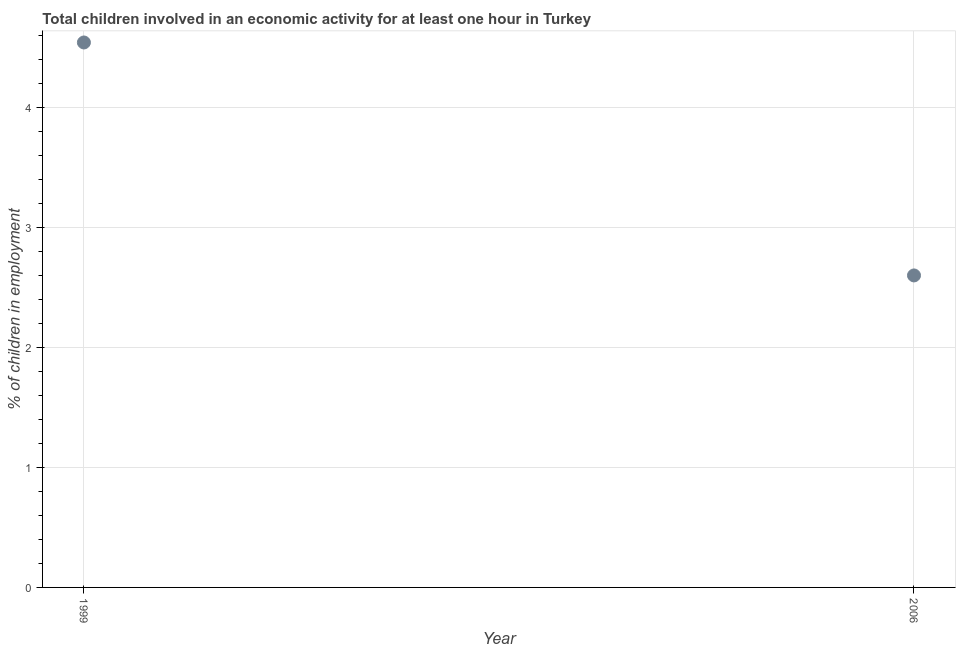What is the percentage of children in employment in 1999?
Ensure brevity in your answer.  4.54. Across all years, what is the maximum percentage of children in employment?
Offer a terse response. 4.54. Across all years, what is the minimum percentage of children in employment?
Your answer should be compact. 2.6. What is the sum of the percentage of children in employment?
Offer a terse response. 7.14. What is the difference between the percentage of children in employment in 1999 and 2006?
Offer a terse response. 1.94. What is the average percentage of children in employment per year?
Your response must be concise. 3.57. What is the median percentage of children in employment?
Offer a terse response. 3.57. Do a majority of the years between 2006 and 1999 (inclusive) have percentage of children in employment greater than 4 %?
Make the answer very short. No. What is the ratio of the percentage of children in employment in 1999 to that in 2006?
Your response must be concise. 1.75. How many dotlines are there?
Your answer should be compact. 1. How many years are there in the graph?
Your answer should be very brief. 2. Does the graph contain any zero values?
Your answer should be compact. No. Does the graph contain grids?
Offer a terse response. Yes. What is the title of the graph?
Your answer should be compact. Total children involved in an economic activity for at least one hour in Turkey. What is the label or title of the X-axis?
Ensure brevity in your answer.  Year. What is the label or title of the Y-axis?
Your response must be concise. % of children in employment. What is the % of children in employment in 1999?
Offer a terse response. 4.54. What is the difference between the % of children in employment in 1999 and 2006?
Make the answer very short. 1.94. What is the ratio of the % of children in employment in 1999 to that in 2006?
Offer a very short reply. 1.75. 